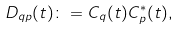Convert formula to latex. <formula><loc_0><loc_0><loc_500><loc_500>D _ { q p } ( t ) \colon = C _ { q } ( t ) C _ { p } ^ { * } ( t ) ,</formula> 